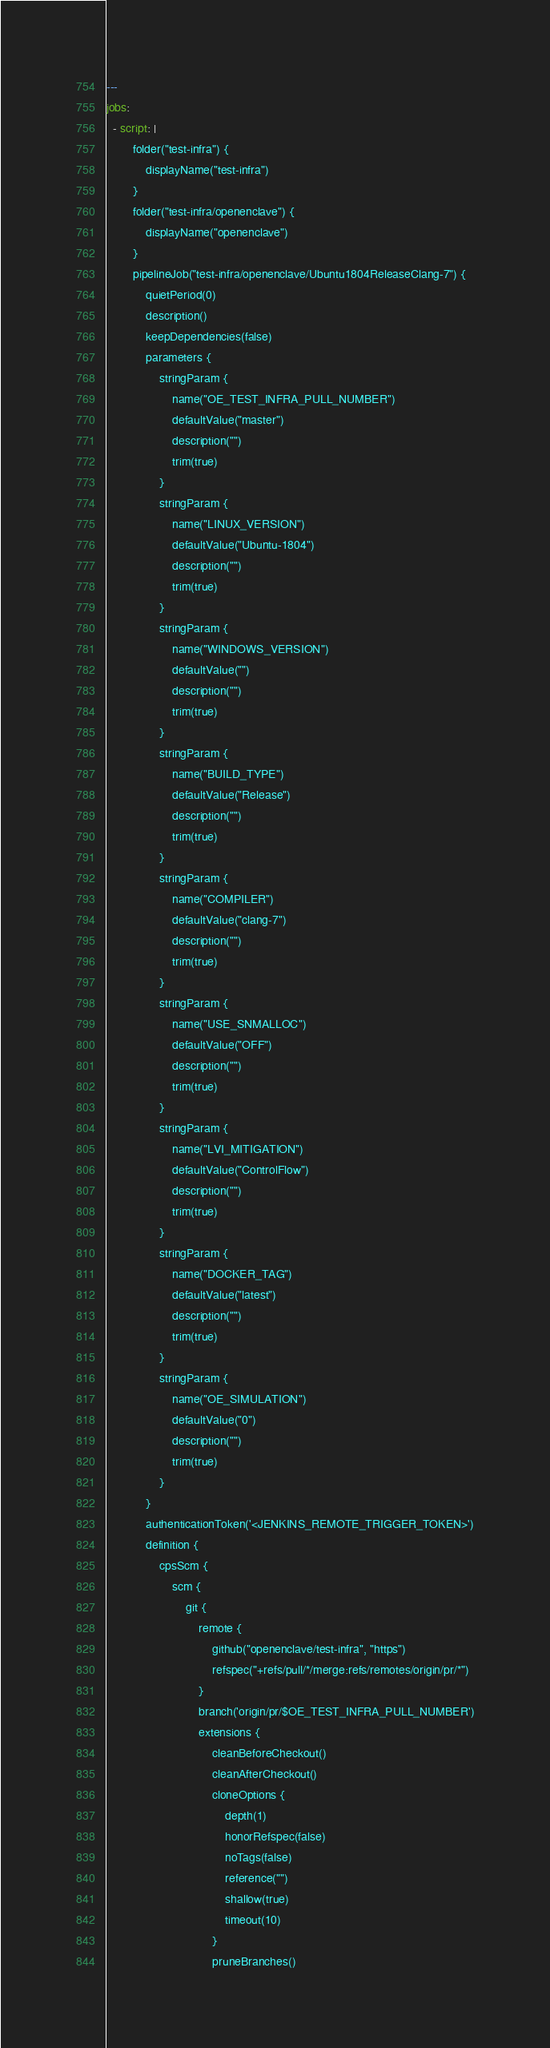Convert code to text. <code><loc_0><loc_0><loc_500><loc_500><_YAML_>---
jobs:
  - script: |
        folder("test-infra") {
            displayName("test-infra")
        }
        folder("test-infra/openenclave") {
            displayName("openenclave")
        }
        pipelineJob("test-infra/openenclave/Ubuntu1804ReleaseClang-7") {
            quietPeriod(0)
            description()
            keepDependencies(false)
            parameters {
                stringParam {
                    name("OE_TEST_INFRA_PULL_NUMBER")
                    defaultValue("master")
                    description("")
                    trim(true)
                }
                stringParam {
                    name("LINUX_VERSION")
                    defaultValue("Ubuntu-1804")
                    description("")
                    trim(true)
                }
                stringParam {
                    name("WINDOWS_VERSION")
                    defaultValue("")
                    description("")
                    trim(true)
                }
                stringParam {
                    name("BUILD_TYPE")
                    defaultValue("Release")
                    description("")
                    trim(true)
                }
                stringParam {
                    name("COMPILER")
                    defaultValue("clang-7")
                    description("")
                    trim(true)
                }
                stringParam {
                    name("USE_SNMALLOC")
                    defaultValue("OFF")
                    description("")
                    trim(true)
                }
                stringParam {
                    name("LVI_MITIGATION")
                    defaultValue("ControlFlow")
                    description("")
                    trim(true)
                }
                stringParam {
                    name("DOCKER_TAG")
                    defaultValue("latest")
                    description("")
                    trim(true)
                }
                stringParam {
                    name("OE_SIMULATION")
                    defaultValue("0")
                    description("")
                    trim(true)
                }
            }
            authenticationToken('<JENKINS_REMOTE_TRIGGER_TOKEN>')
            definition {
                cpsScm {
                    scm {
                        git {
                            remote {
                                github("openenclave/test-infra", "https")
                                refspec("+refs/pull/*/merge:refs/remotes/origin/pr/*")
                            }
                            branch('origin/pr/$OE_TEST_INFRA_PULL_NUMBER')
                            extensions {
                                cleanBeforeCheckout()
                                cleanAfterCheckout()
                                cloneOptions {
                                    depth(1)
                                    honorRefspec(false)
                                    noTags(false)
                                    reference("")
                                    shallow(true)
                                    timeout(10)
                                }
                                pruneBranches()</code> 